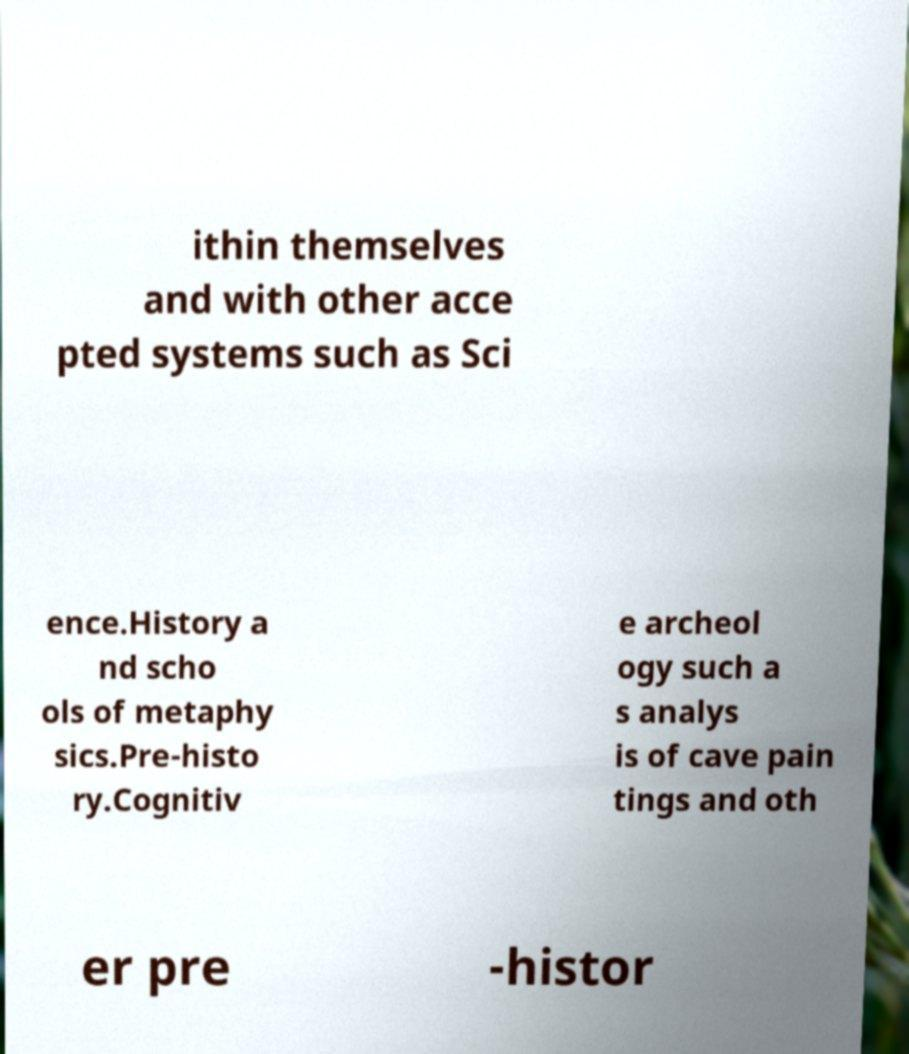What messages or text are displayed in this image? I need them in a readable, typed format. ithin themselves and with other acce pted systems such as Sci ence.History a nd scho ols of metaphy sics.Pre-histo ry.Cognitiv e archeol ogy such a s analys is of cave pain tings and oth er pre -histor 